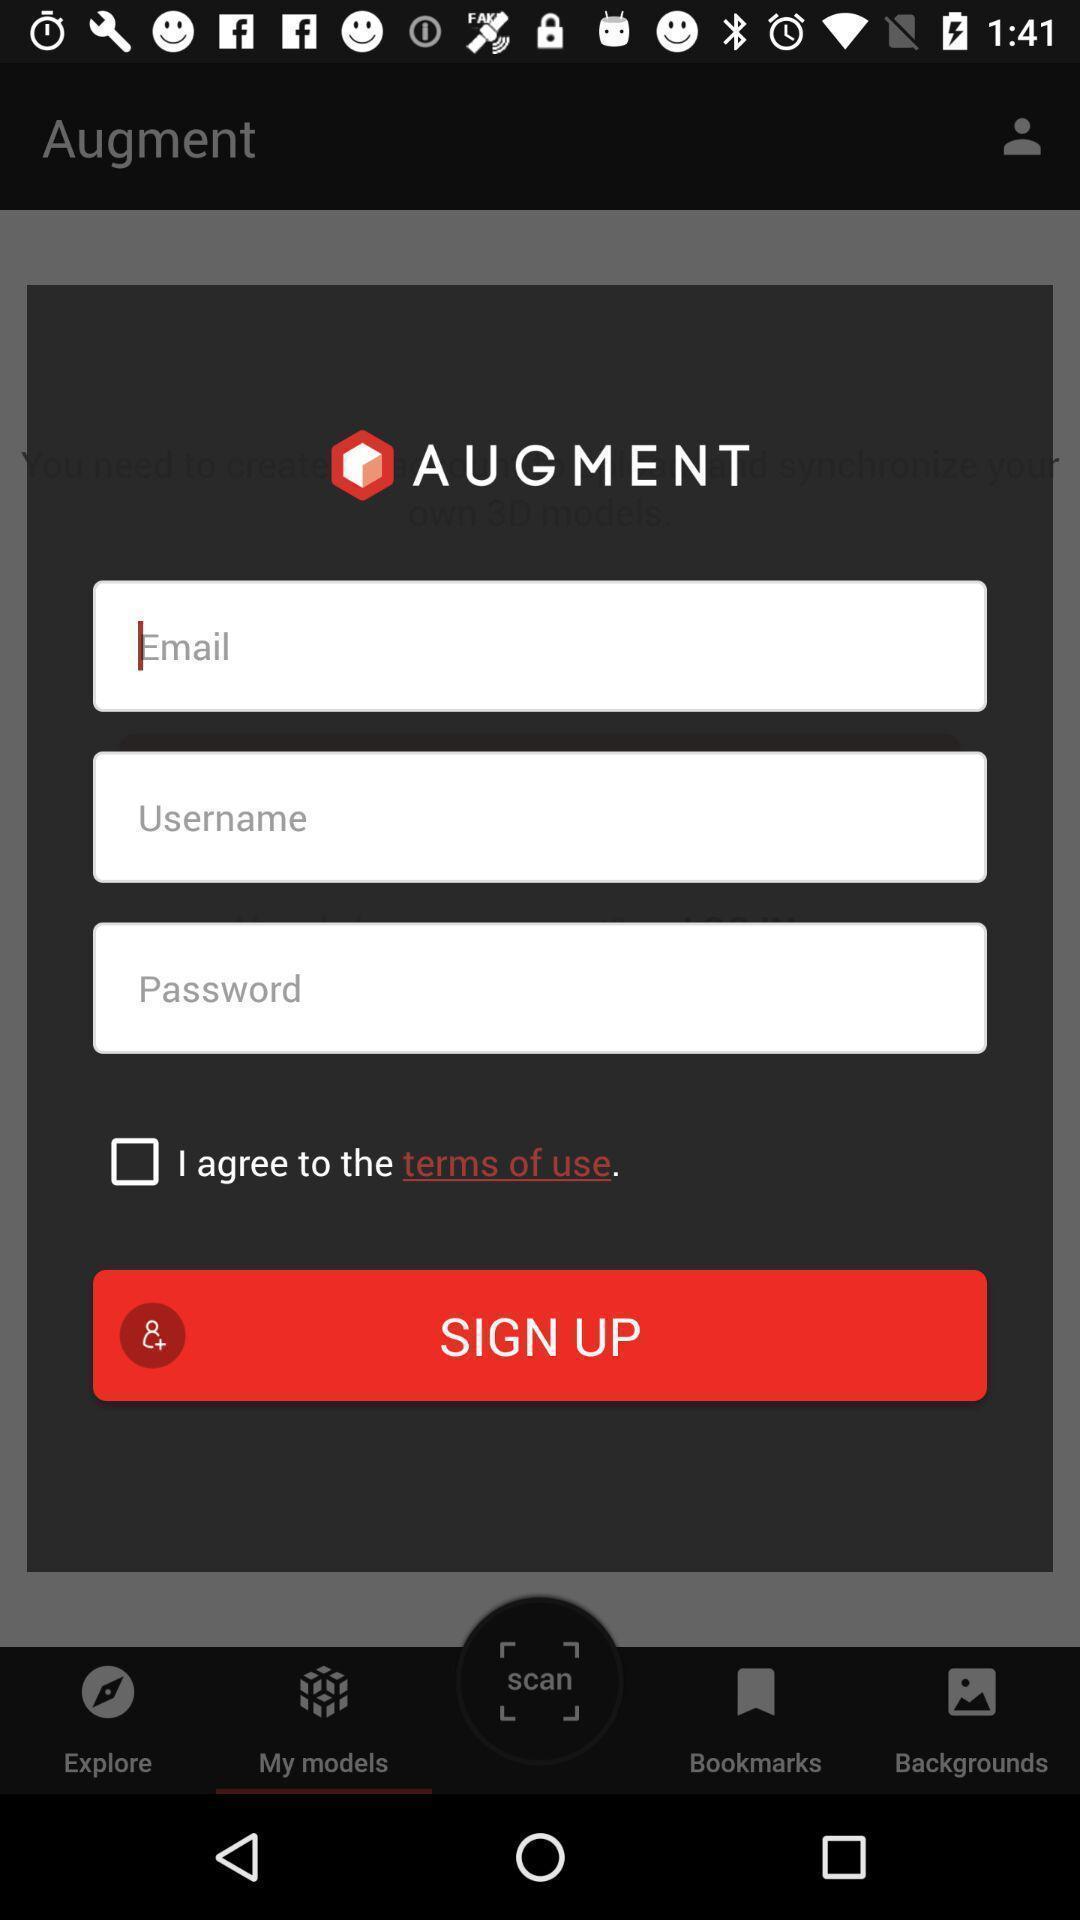Describe the content in this image. Sign in page with sign-up button in an service application. 